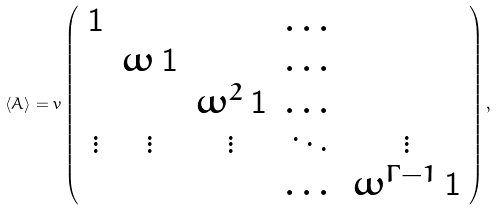Convert formula to latex. <formula><loc_0><loc_0><loc_500><loc_500>\langle A \rangle = v \left ( \begin{array} { c c c c c } { \mathbf 1 } & & & \dots & \\ & \omega \, { \mathbf 1 } & & \dots & \\ & & \omega ^ { 2 } \, { \mathbf 1 } & \dots & \\ \vdots & \vdots & \vdots & \ddots & \vdots \\ & & & \dots & \omega ^ { \Gamma - 1 } \, { \mathbf 1 } \end{array} \right ) ,</formula> 